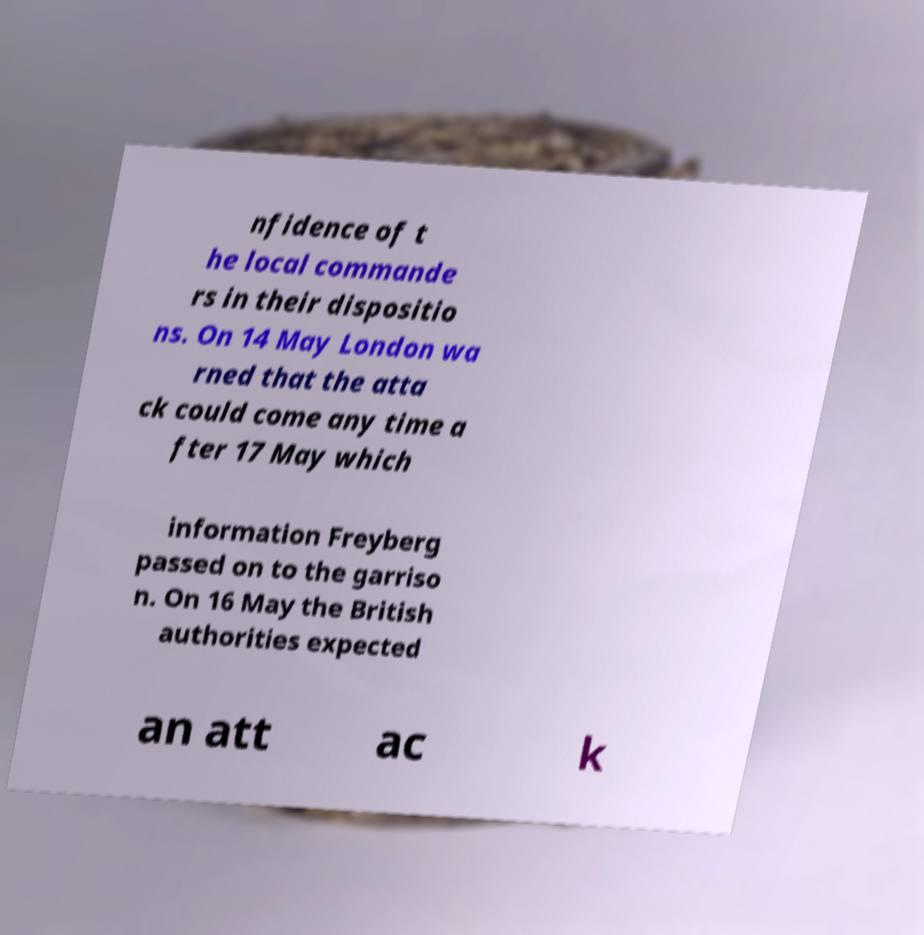Could you extract and type out the text from this image? nfidence of t he local commande rs in their dispositio ns. On 14 May London wa rned that the atta ck could come any time a fter 17 May which information Freyberg passed on to the garriso n. On 16 May the British authorities expected an att ac k 